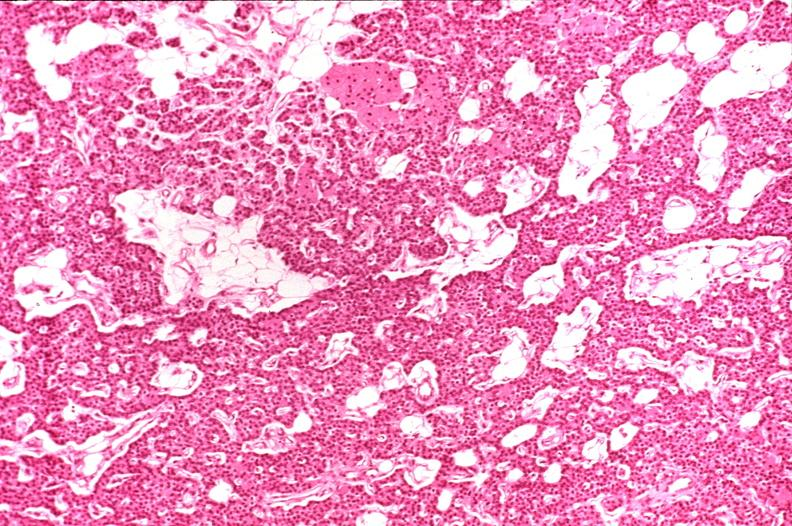where is this part in the figure?
Answer the question using a single word or phrase. Endocrine system 